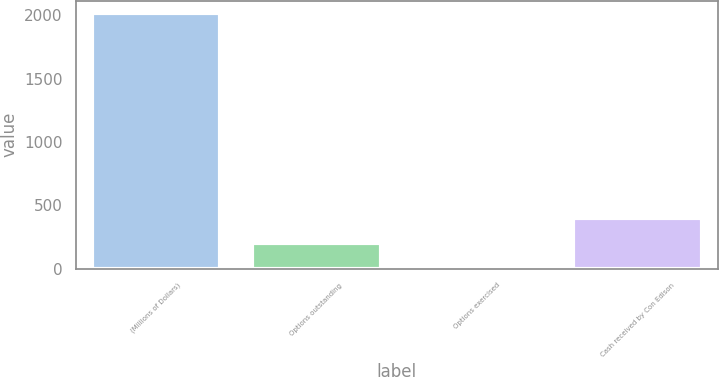<chart> <loc_0><loc_0><loc_500><loc_500><bar_chart><fcel>(Millions of Dollars)<fcel>Options outstanding<fcel>Options exercised<fcel>Cash received by Con Edison<nl><fcel>2014<fcel>204.1<fcel>3<fcel>405.2<nl></chart> 